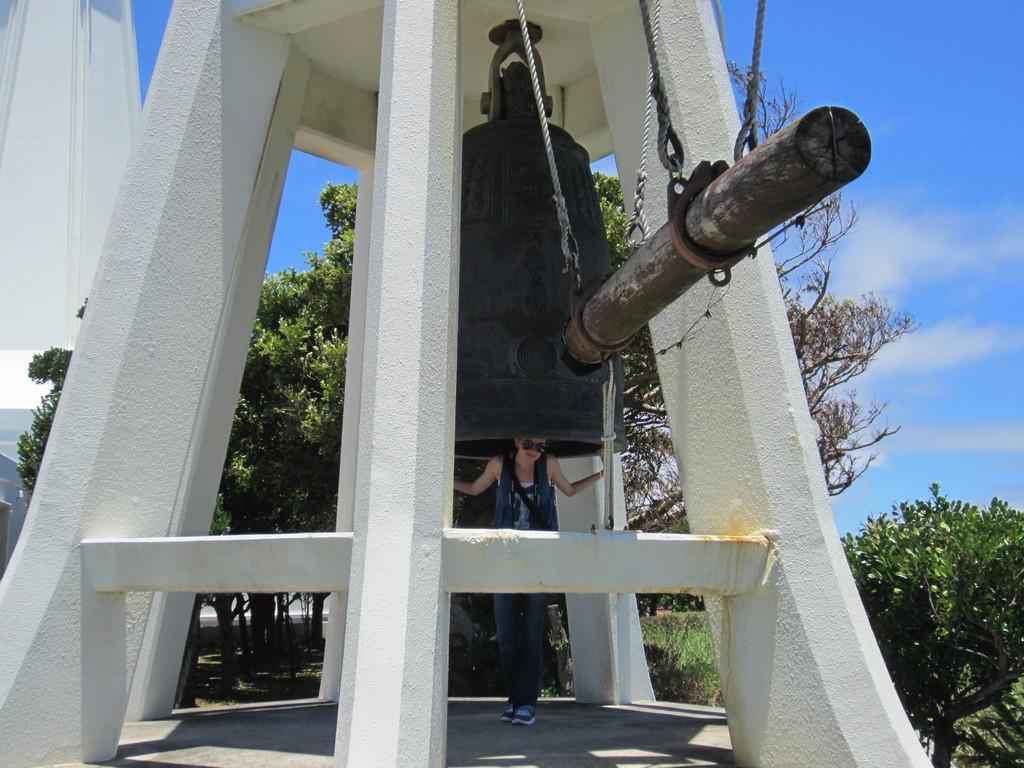Please provide a concise description of this image. In the center of the image we can see bellperson and stick. In the background we can see building, trees, plants, sky and clouds. 